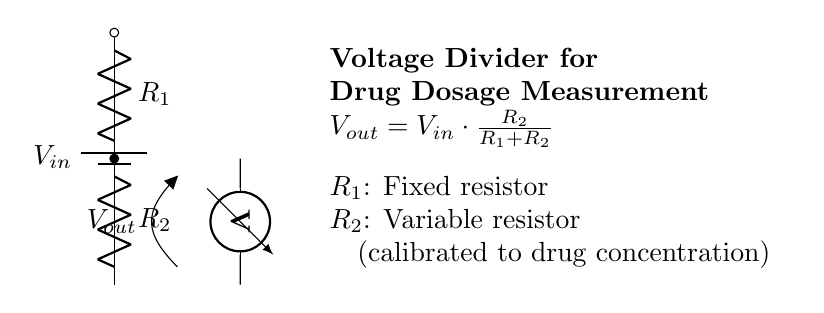What is the purpose of the variable resistor in this circuit? The variable resistor, labeled as R2, is calibrated to adjust the output voltage based on the drug concentration for precise drug dosage measurement. This allows for fine-tuning the dosage according to the specific requirements.
Answer: Variable resistor What is the formula for the output voltage in this circuit? The output voltage, Vout, is calculated using the formula \( V_{out} = V_{in} \cdot \frac{R_2}{R_1+R_2} \). This shows that Vout is directly proportional to the input voltage and the resistance value of R2.
Answer: Vout = Vin * (R2 / (R1 + R2)) What type of circuit is depicted in the diagram? The circuit represented is a voltage divider circuit. This configuration is commonly used to obtain a portion of the input voltage through the use of two resistors, making it suitable for applications such as drug dosage measurement.
Answer: Voltage divider What is the function of the voltmeter in the circuit? The voltmeter measures the output voltage (Vout) across the variable resistor R2, providing a direct indication of the voltage level used for drug dosage determination. This is critical for ensuring accurate dosing.
Answer: Measure output voltage How does changing R2 affect Vout? Changing R2 alters the ratio in the voltage divider formula, which modifies Vout. If R2 increases, Vout increases, while decreasing R2 leads to a lower Vout, allowing for dynamic adjustment based on drug concentration.
Answer: Changes Vout What happens if R1 is zero in this circuit? If R1 is zero, it creates a short circuit across the input voltage, resulting in undefined behavior for the voltage divider, as it would theoretically lead to maximum current flow and potentially damage the circuit.
Answer: Short circuit 